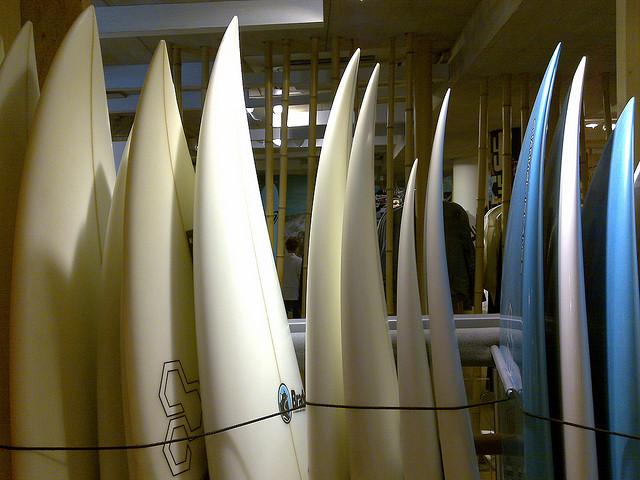How many surfboards are there?
Short answer required. 11. What two colors are the surfboards?
Short answer required. White and blue. What is the number of surfboards?
Short answer required. 11. 